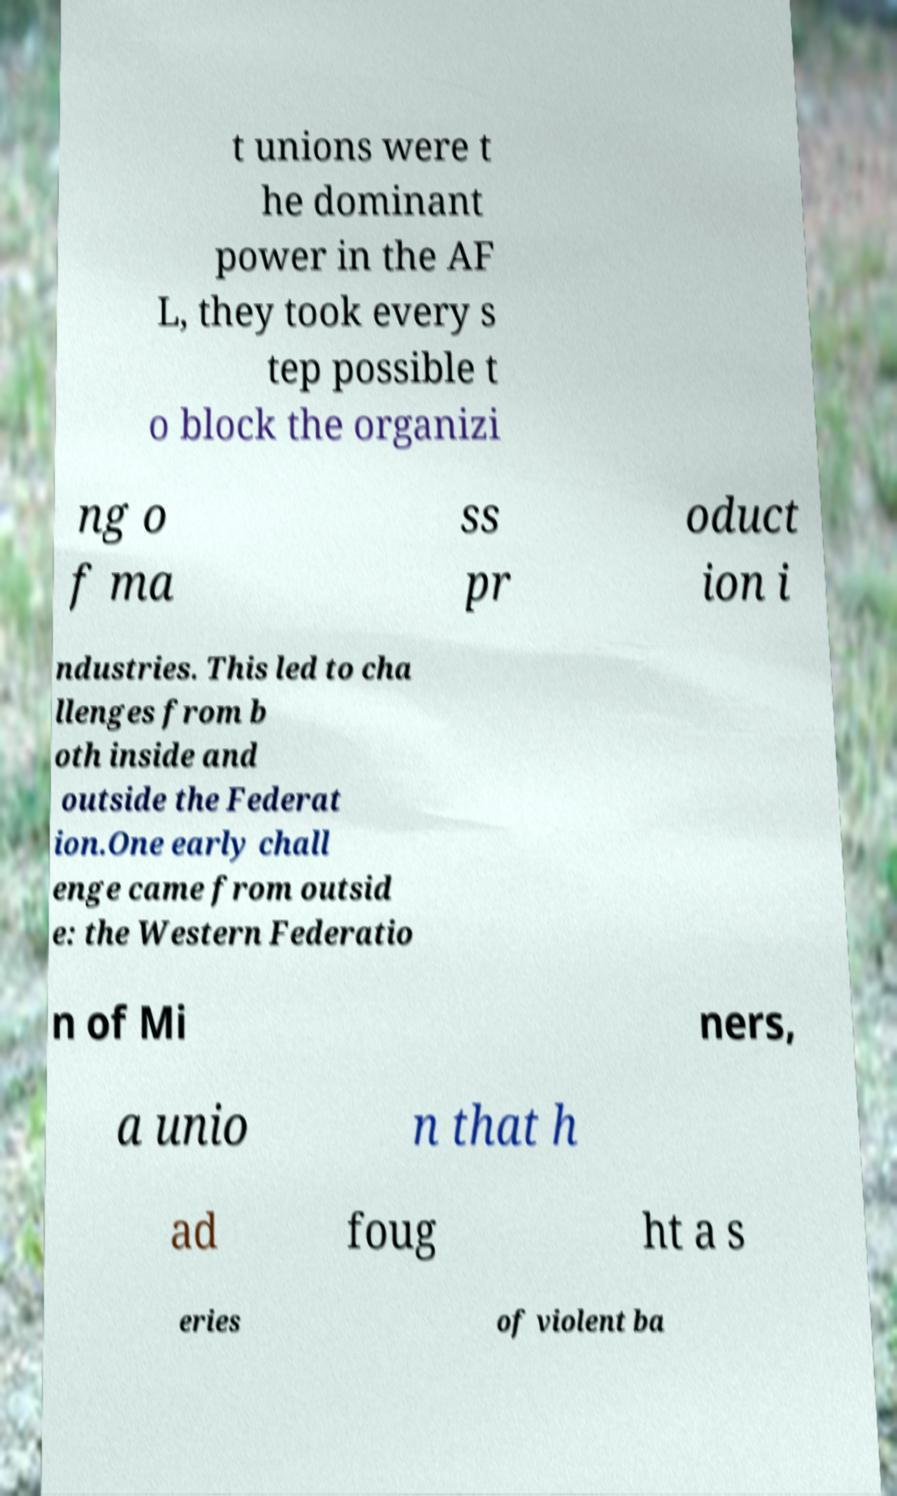Can you read and provide the text displayed in the image?This photo seems to have some interesting text. Can you extract and type it out for me? t unions were t he dominant power in the AF L, they took every s tep possible t o block the organizi ng o f ma ss pr oduct ion i ndustries. This led to cha llenges from b oth inside and outside the Federat ion.One early chall enge came from outsid e: the Western Federatio n of Mi ners, a unio n that h ad foug ht a s eries of violent ba 